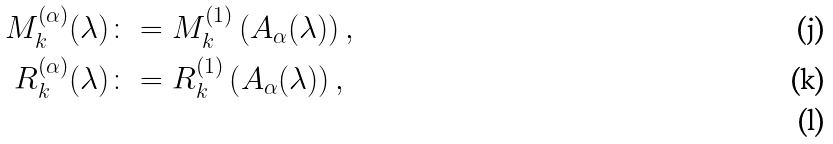<formula> <loc_0><loc_0><loc_500><loc_500>M _ { k } ^ { ( \alpha ) } ( \lambda ) & \colon = M ^ { ( 1 ) } _ { k } \left ( A _ { \alpha } ( \lambda ) \right ) , \\ R _ { k } ^ { ( \alpha ) } ( \lambda ) & \colon = R ^ { ( 1 ) } _ { k } \left ( A _ { \alpha } ( \lambda ) \right ) , \\</formula> 